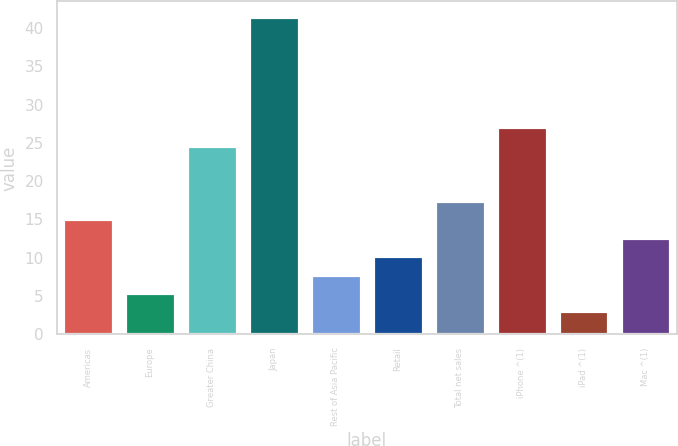<chart> <loc_0><loc_0><loc_500><loc_500><bar_chart><fcel>Americas<fcel>Europe<fcel>Greater China<fcel>Japan<fcel>Rest of Asia Pacific<fcel>Retail<fcel>Total net sales<fcel>iPhone ^(1)<fcel>iPad ^(1)<fcel>Mac ^(1)<nl><fcel>15<fcel>5.4<fcel>24.6<fcel>41.4<fcel>7.8<fcel>10.2<fcel>17.4<fcel>27<fcel>3<fcel>12.6<nl></chart> 